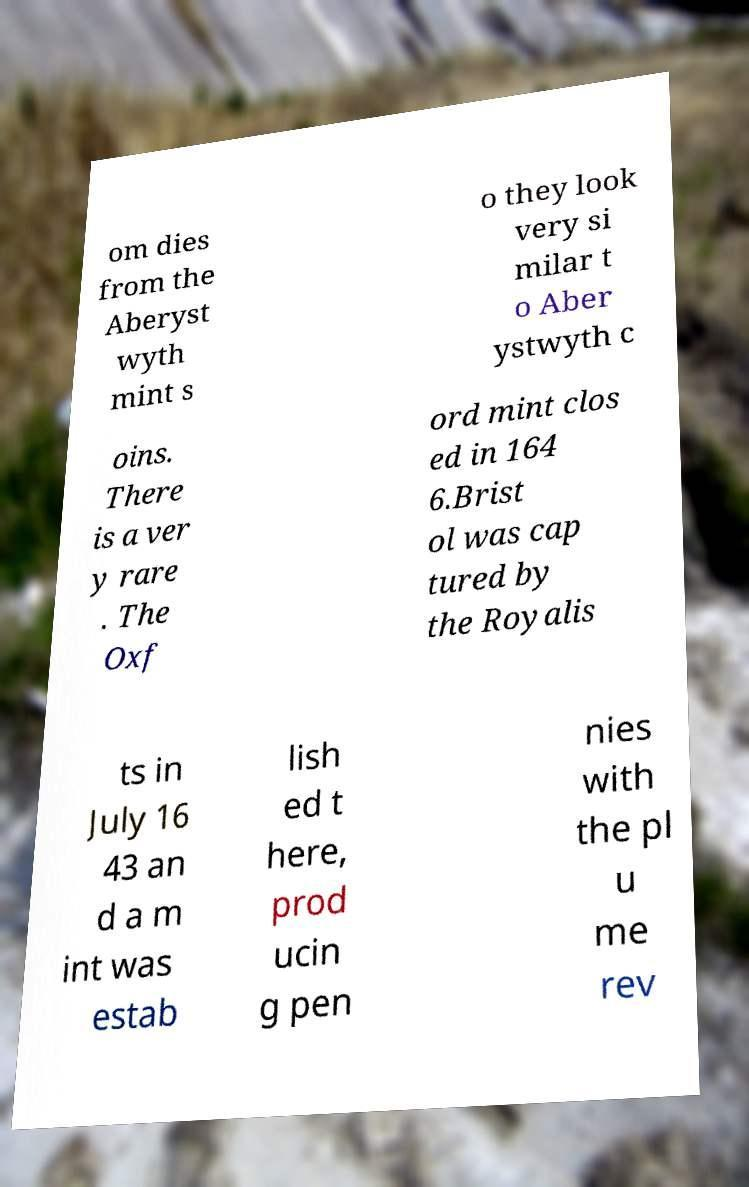Please identify and transcribe the text found in this image. om dies from the Aberyst wyth mint s o they look very si milar t o Aber ystwyth c oins. There is a ver y rare . The Oxf ord mint clos ed in 164 6.Brist ol was cap tured by the Royalis ts in July 16 43 an d a m int was estab lish ed t here, prod ucin g pen nies with the pl u me rev 